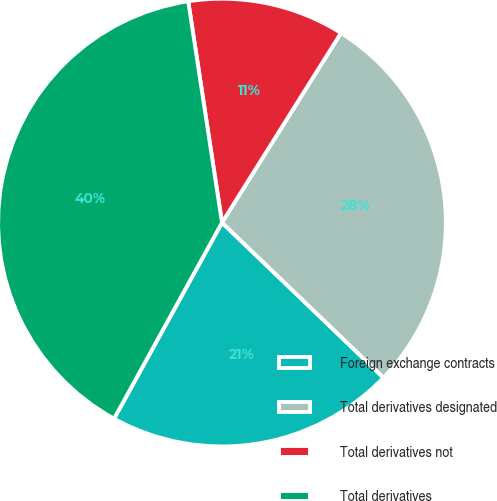Convert chart. <chart><loc_0><loc_0><loc_500><loc_500><pie_chart><fcel>Foreign exchange contracts<fcel>Total derivatives designated<fcel>Total derivatives not<fcel>Total derivatives<nl><fcel>20.83%<fcel>28.26%<fcel>11.33%<fcel>39.58%<nl></chart> 